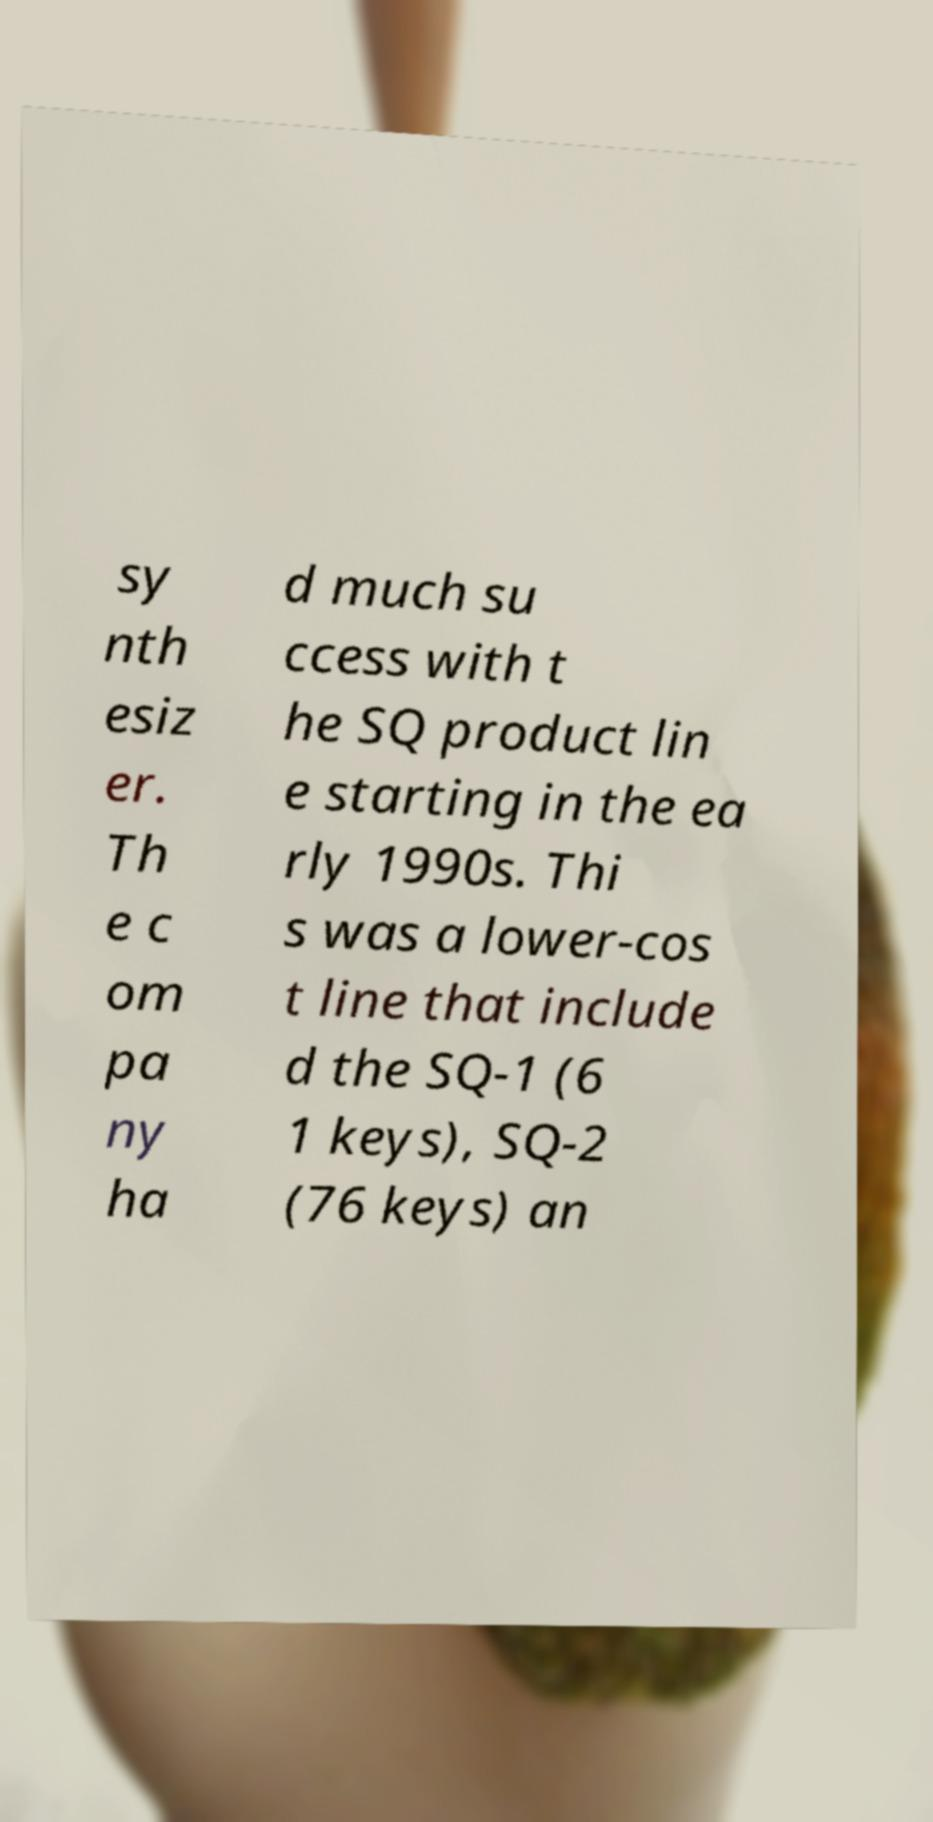What messages or text are displayed in this image? I need them in a readable, typed format. sy nth esiz er. Th e c om pa ny ha d much su ccess with t he SQ product lin e starting in the ea rly 1990s. Thi s was a lower-cos t line that include d the SQ-1 (6 1 keys), SQ-2 (76 keys) an 